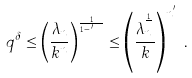Convert formula to latex. <formula><loc_0><loc_0><loc_500><loc_500>q ^ { \delta } \leq \left ( \frac { \lambda _ { n } } { k ^ { n } } \right ) ^ { \frac { 1 } { n ^ { 1 - \epsilon ^ { \prime } } } } \leq \left ( \frac { \lambda _ { n } ^ { \frac { 1 } { n } } } { k } \right ) ^ { n ^ { \epsilon ^ { \prime } } } .</formula> 